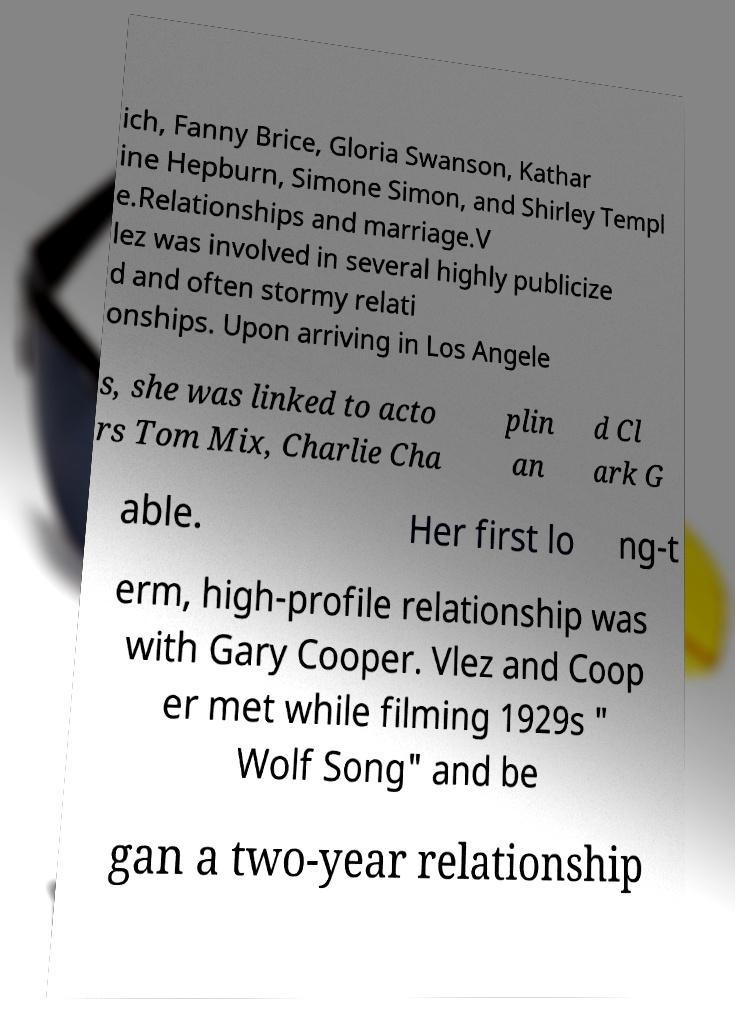Please identify and transcribe the text found in this image. ich, Fanny Brice, Gloria Swanson, Kathar ine Hepburn, Simone Simon, and Shirley Templ e.Relationships and marriage.V lez was involved in several highly publicize d and often stormy relati onships. Upon arriving in Los Angele s, she was linked to acto rs Tom Mix, Charlie Cha plin an d Cl ark G able. Her first lo ng-t erm, high-profile relationship was with Gary Cooper. Vlez and Coop er met while filming 1929s " Wolf Song" and be gan a two-year relationship 